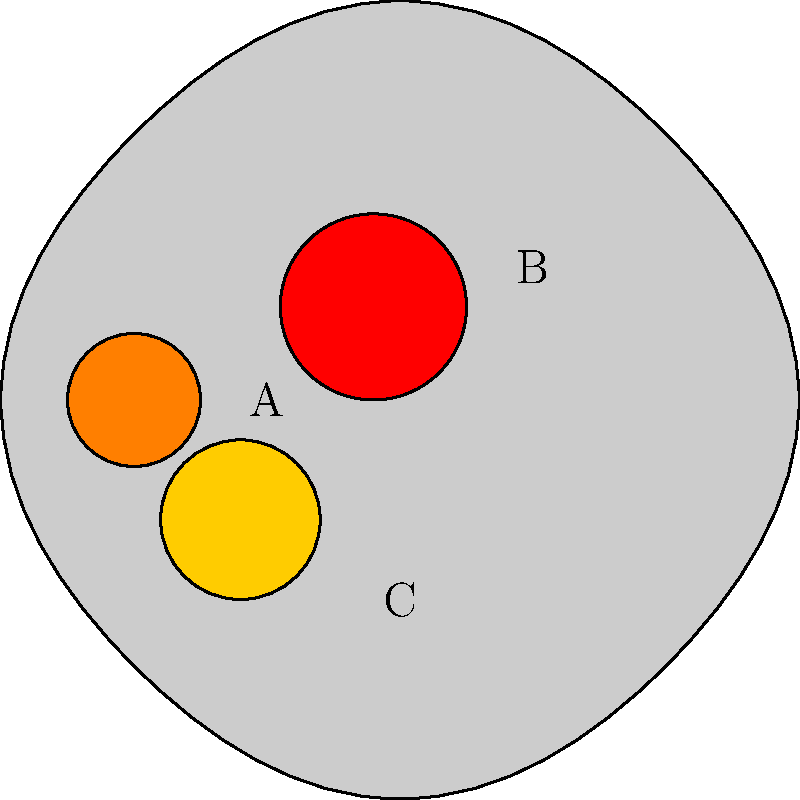In the fMRI heat map of brain activity shown above, which region exhibits the highest level of activation, and what statistical measure would you use to quantify the significance of this activation compared to baseline? To answer this question, we need to follow these steps:

1. Analyze the heat map:
   The image shows a simplified brain outline with three regions of activation (A, B, and C) represented by different colors.

2. Interpret the color scale:
   In fMRI heat maps, warmer colors (red) typically indicate higher levels of activation, while cooler colors (yellow, orange) indicate lower levels.

3. Identify the region with highest activation:
   Region B (center-right) appears to be the most intense red, indicating the highest level of activation.

4. Consider statistical measures:
   To quantify the significance of activation compared to baseline, we typically use:
   
   a) t-statistic: Measures the difference between the activation and baseline, normalized by the variability.
   b) z-score: Similar to t-statistic but based on the standard normal distribution.
   c) p-value: Indicates the probability of observing such activation by chance.

5. Choose the most appropriate measure:
   The t-statistic is commonly used in fMRI analysis because it accounts for both the magnitude of activation and its consistency across participants or time points.

   The t-statistic is calculated as:

   $$ t = \frac{\bar{X} - \mu_0}{s / \sqrt{n}} $$

   Where:
   $\bar{X}$ is the mean activation in the region
   $\mu_0$ is the baseline activation
   $s$ is the standard deviation of the activation
   $n$ is the number of observations

6. Conclusion:
   Region B shows the highest activation, and the t-statistic would be an appropriate measure to quantify its significance compared to baseline.
Answer: Region B; t-statistic 